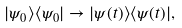Convert formula to latex. <formula><loc_0><loc_0><loc_500><loc_500>| \psi _ { 0 } \rangle \langle \psi _ { 0 } | \to | \psi ( t ) \rangle \langle \psi ( t ) | ,</formula> 